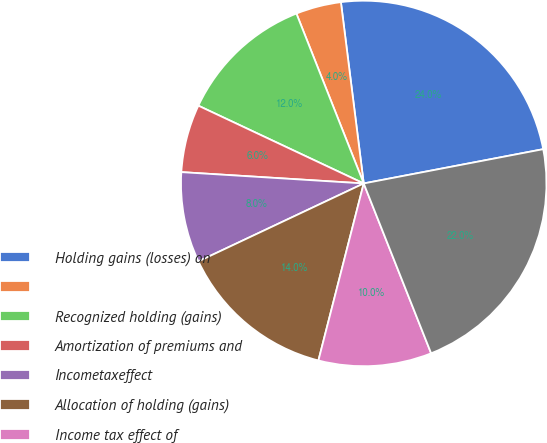<chart> <loc_0><loc_0><loc_500><loc_500><pie_chart><fcel>Holding gains (losses) on<fcel>Unnamed: 1<fcel>Recognized holding (gains)<fcel>Amortization of premiums and<fcel>Incometaxeffect<fcel>Allocation of holding (gains)<fcel>Income tax effect of<fcel>Net unrealized investment<nl><fcel>23.99%<fcel>4.01%<fcel>12.0%<fcel>6.01%<fcel>8.0%<fcel>14.0%<fcel>10.0%<fcel>21.99%<nl></chart> 